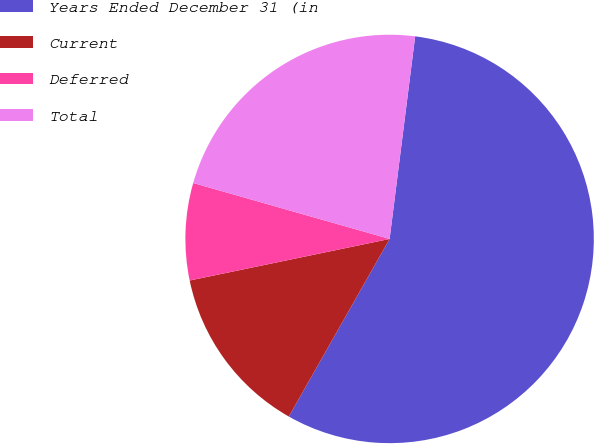Convert chart to OTSL. <chart><loc_0><loc_0><loc_500><loc_500><pie_chart><fcel>Years Ended December 31 (in<fcel>Current<fcel>Deferred<fcel>Total<nl><fcel>56.22%<fcel>13.52%<fcel>7.68%<fcel>22.58%<nl></chart> 